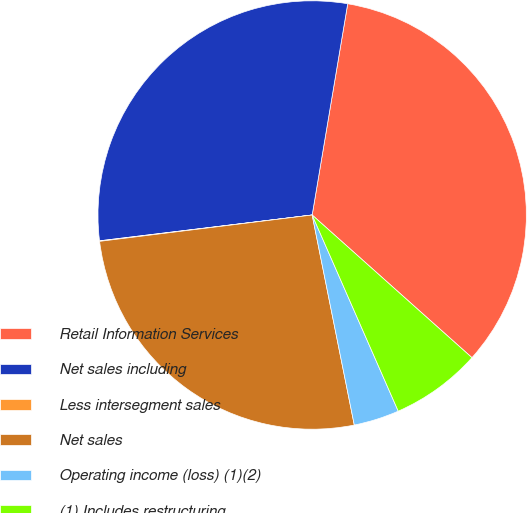Convert chart. <chart><loc_0><loc_0><loc_500><loc_500><pie_chart><fcel>Retail Information Services<fcel>Net sales including<fcel>Less intersegment sales<fcel>Net sales<fcel>Operating income (loss) (1)(2)<fcel>(1) Includes restructuring<nl><fcel>33.95%<fcel>29.58%<fcel>0.04%<fcel>26.19%<fcel>3.43%<fcel>6.82%<nl></chart> 